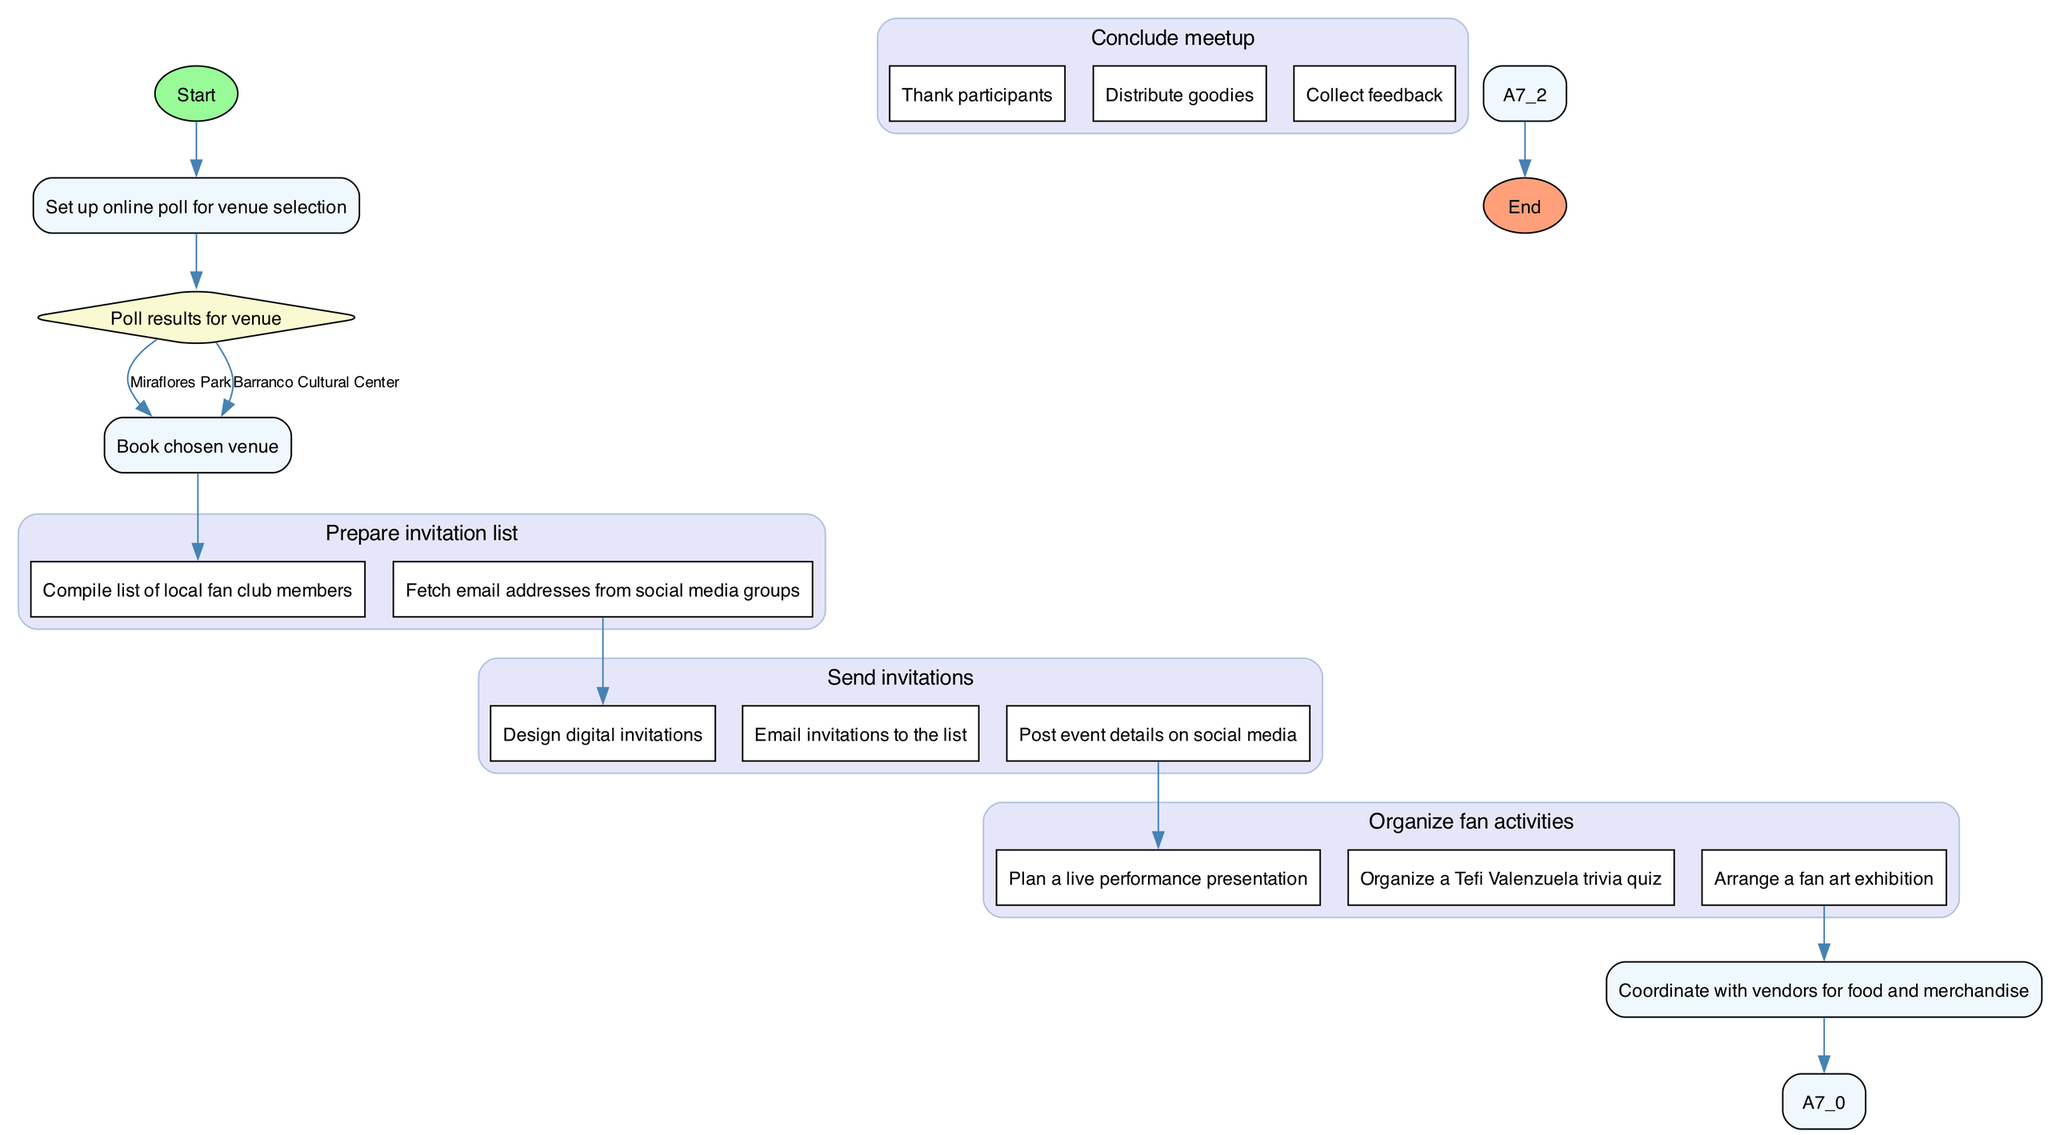What is the first activity in the diagram? The diagram begins with the 'Initiate fan meetup planning' node, which is the first step or activity identified in the sequence.
Answer: Initiate fan meetup planning How many activities are depicted in the diagram? There are a total of six main activities outlined, including decision-making and sub-activities for preparing and concluding the meetup.
Answer: Six What are the two venue options available in the decision node? The decision node lists two venue options: "Miraflores Park" and "Barranco Cultural Center" that fans can vote on for selecting the meetup location.
Answer: Miraflores Park, Barranco Cultural Center What comes after booking the venue? After booking the chosen venue, the next activity in the diagram is to 'Prepare invitation list', signifying the transition to the next step in the planning process.
Answer: Prepare invitation list What do the tasks for 'Send invitations' involve? The tasks involved in 'Send invitations' include designing digital invitations, emailing them to the list, and posting event details on social media, which collectively ensure that fans are informed about the meetup.
Answer: Design digital invitations, Email invitations to the list, Post event details on social media What happens at the end of the meetup? At the conclusion of the meetup, tasks include thanking participants, distributing goodies, and collecting feedback, which serve as final activities to wrap up the event.
Answer: Thank participants, Distribute goodies, Collect feedback Which activity directly follows 'Organize fan activities'? The activity that directly follows 'Organize fan activities' is 'Coordinate with vendors for food and merchandise', indicating a progression in the event planning process.
Answer: Coordinate with vendors for food and merchandise 